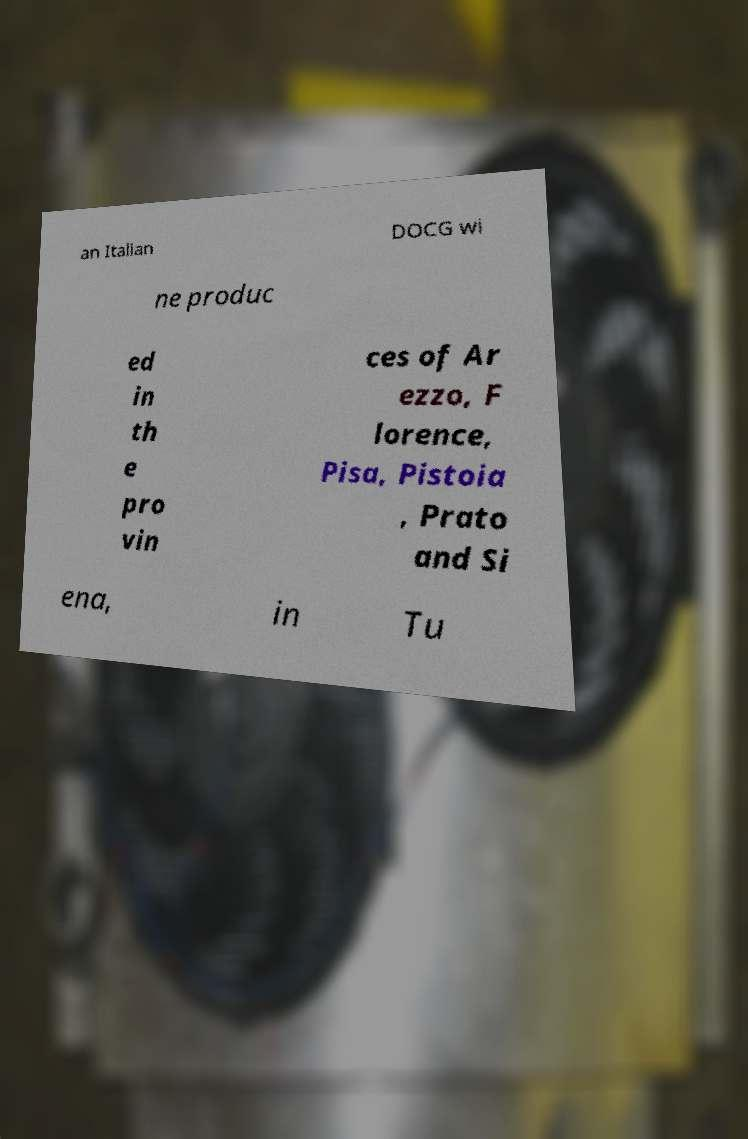Please read and relay the text visible in this image. What does it say? an Italian DOCG wi ne produc ed in th e pro vin ces of Ar ezzo, F lorence, Pisa, Pistoia , Prato and Si ena, in Tu 